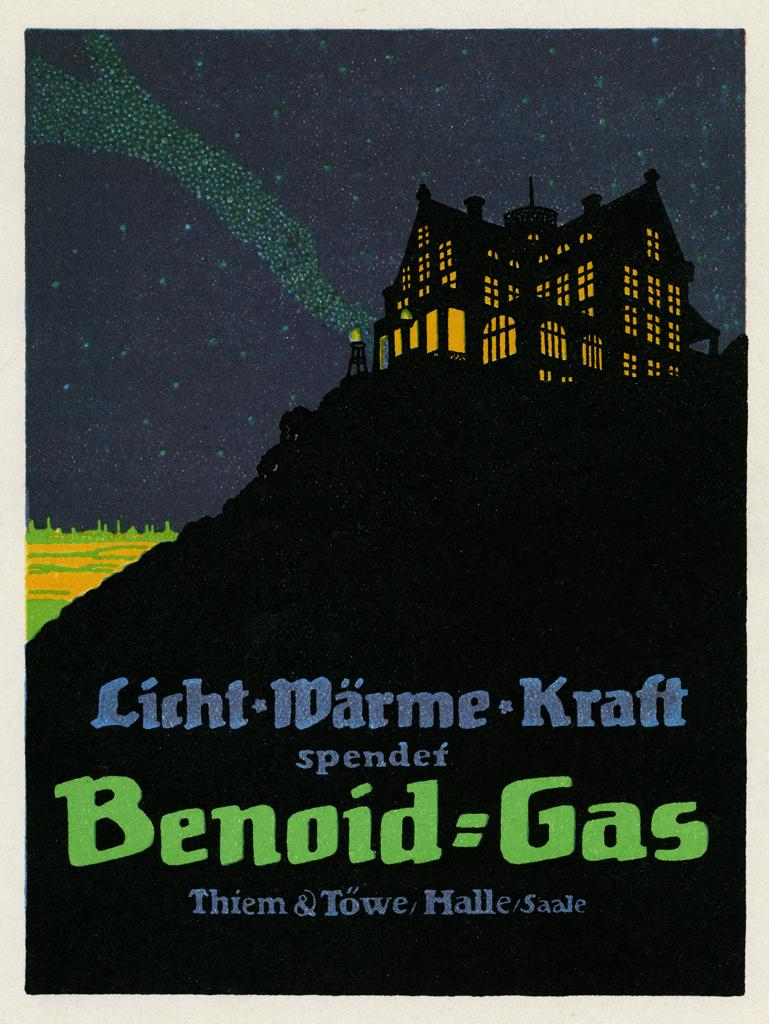<image>
Write a terse but informative summary of the picture. drawing of a lighted building on a mountaintop at night and some words benoid=gas at bottom 